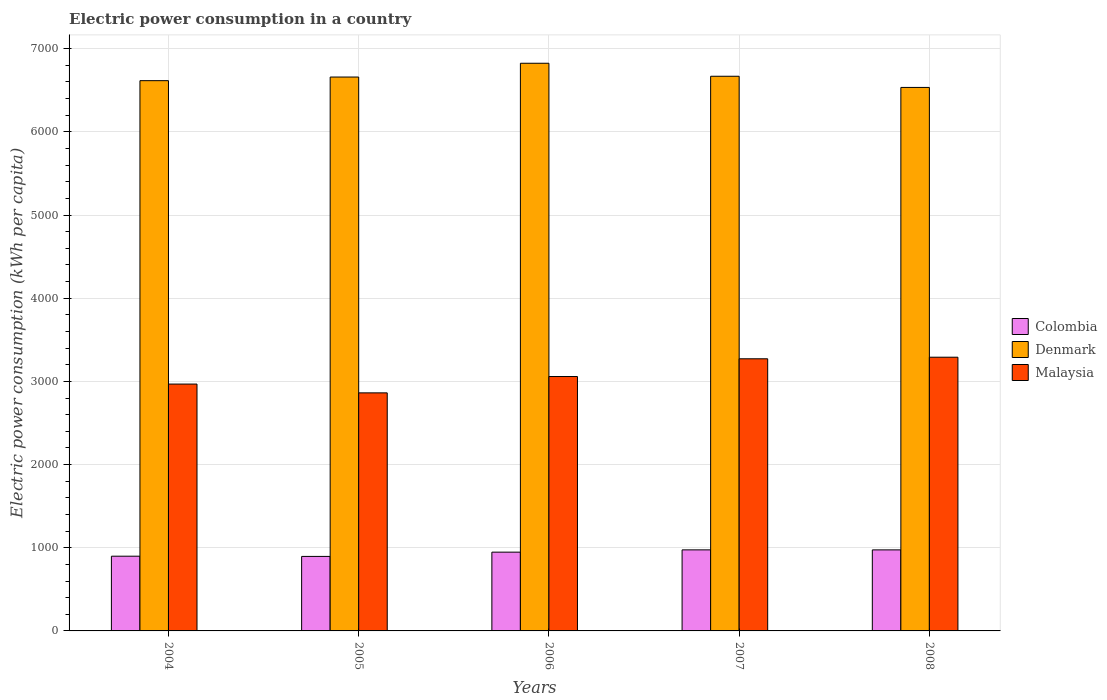How many different coloured bars are there?
Offer a terse response. 3. How many groups of bars are there?
Give a very brief answer. 5. What is the label of the 5th group of bars from the left?
Make the answer very short. 2008. In how many cases, is the number of bars for a given year not equal to the number of legend labels?
Give a very brief answer. 0. What is the electric power consumption in in Colombia in 2005?
Offer a very short reply. 895.82. Across all years, what is the maximum electric power consumption in in Denmark?
Your answer should be very brief. 6824.75. Across all years, what is the minimum electric power consumption in in Denmark?
Offer a terse response. 6534.12. In which year was the electric power consumption in in Colombia minimum?
Offer a terse response. 2005. What is the total electric power consumption in in Denmark in the graph?
Keep it short and to the point. 3.33e+04. What is the difference between the electric power consumption in in Malaysia in 2004 and that in 2007?
Provide a short and direct response. -303.94. What is the difference between the electric power consumption in in Denmark in 2005 and the electric power consumption in in Malaysia in 2004?
Your answer should be compact. 3691.29. What is the average electric power consumption in in Colombia per year?
Give a very brief answer. 937.98. In the year 2004, what is the difference between the electric power consumption in in Malaysia and electric power consumption in in Denmark?
Offer a terse response. -3647.86. What is the ratio of the electric power consumption in in Malaysia in 2006 to that in 2008?
Provide a short and direct response. 0.93. Is the electric power consumption in in Denmark in 2004 less than that in 2006?
Your answer should be very brief. Yes. Is the difference between the electric power consumption in in Malaysia in 2005 and 2006 greater than the difference between the electric power consumption in in Denmark in 2005 and 2006?
Give a very brief answer. No. What is the difference between the highest and the second highest electric power consumption in in Denmark?
Make the answer very short. 156.36. What is the difference between the highest and the lowest electric power consumption in in Malaysia?
Give a very brief answer. 428.77. What does the 1st bar from the right in 2004 represents?
Your answer should be very brief. Malaysia. How many bars are there?
Offer a very short reply. 15. How many years are there in the graph?
Your response must be concise. 5. What is the difference between two consecutive major ticks on the Y-axis?
Provide a short and direct response. 1000. Are the values on the major ticks of Y-axis written in scientific E-notation?
Your answer should be very brief. No. Does the graph contain any zero values?
Provide a short and direct response. No. Does the graph contain grids?
Offer a very short reply. Yes. Where does the legend appear in the graph?
Provide a short and direct response. Center right. What is the title of the graph?
Make the answer very short. Electric power consumption in a country. What is the label or title of the X-axis?
Your response must be concise. Years. What is the label or title of the Y-axis?
Your answer should be compact. Electric power consumption (kWh per capita). What is the Electric power consumption (kWh per capita) in Colombia in 2004?
Give a very brief answer. 898.34. What is the Electric power consumption (kWh per capita) of Denmark in 2004?
Give a very brief answer. 6615.57. What is the Electric power consumption (kWh per capita) of Malaysia in 2004?
Offer a terse response. 2967.71. What is the Electric power consumption (kWh per capita) of Colombia in 2005?
Offer a terse response. 895.82. What is the Electric power consumption (kWh per capita) in Denmark in 2005?
Ensure brevity in your answer.  6659. What is the Electric power consumption (kWh per capita) in Malaysia in 2005?
Offer a very short reply. 2861.98. What is the Electric power consumption (kWh per capita) of Colombia in 2006?
Make the answer very short. 947.13. What is the Electric power consumption (kWh per capita) of Denmark in 2006?
Offer a terse response. 6824.75. What is the Electric power consumption (kWh per capita) in Malaysia in 2006?
Your answer should be very brief. 3058.44. What is the Electric power consumption (kWh per capita) of Colombia in 2007?
Ensure brevity in your answer.  974.39. What is the Electric power consumption (kWh per capita) in Denmark in 2007?
Your response must be concise. 6668.39. What is the Electric power consumption (kWh per capita) in Malaysia in 2007?
Provide a short and direct response. 3271.64. What is the Electric power consumption (kWh per capita) of Colombia in 2008?
Keep it short and to the point. 974.22. What is the Electric power consumption (kWh per capita) in Denmark in 2008?
Make the answer very short. 6534.12. What is the Electric power consumption (kWh per capita) of Malaysia in 2008?
Provide a succinct answer. 3290.75. Across all years, what is the maximum Electric power consumption (kWh per capita) of Colombia?
Your answer should be very brief. 974.39. Across all years, what is the maximum Electric power consumption (kWh per capita) of Denmark?
Ensure brevity in your answer.  6824.75. Across all years, what is the maximum Electric power consumption (kWh per capita) of Malaysia?
Your answer should be very brief. 3290.75. Across all years, what is the minimum Electric power consumption (kWh per capita) of Colombia?
Keep it short and to the point. 895.82. Across all years, what is the minimum Electric power consumption (kWh per capita) of Denmark?
Your answer should be very brief. 6534.12. Across all years, what is the minimum Electric power consumption (kWh per capita) of Malaysia?
Your answer should be compact. 2861.98. What is the total Electric power consumption (kWh per capita) in Colombia in the graph?
Your answer should be compact. 4689.89. What is the total Electric power consumption (kWh per capita) of Denmark in the graph?
Provide a short and direct response. 3.33e+04. What is the total Electric power consumption (kWh per capita) of Malaysia in the graph?
Make the answer very short. 1.55e+04. What is the difference between the Electric power consumption (kWh per capita) of Colombia in 2004 and that in 2005?
Provide a succinct answer. 2.53. What is the difference between the Electric power consumption (kWh per capita) in Denmark in 2004 and that in 2005?
Your answer should be very brief. -43.43. What is the difference between the Electric power consumption (kWh per capita) in Malaysia in 2004 and that in 2005?
Your response must be concise. 105.73. What is the difference between the Electric power consumption (kWh per capita) of Colombia in 2004 and that in 2006?
Provide a short and direct response. -48.78. What is the difference between the Electric power consumption (kWh per capita) of Denmark in 2004 and that in 2006?
Provide a succinct answer. -209.18. What is the difference between the Electric power consumption (kWh per capita) in Malaysia in 2004 and that in 2006?
Your answer should be compact. -90.74. What is the difference between the Electric power consumption (kWh per capita) in Colombia in 2004 and that in 2007?
Your answer should be compact. -76.04. What is the difference between the Electric power consumption (kWh per capita) of Denmark in 2004 and that in 2007?
Offer a very short reply. -52.82. What is the difference between the Electric power consumption (kWh per capita) of Malaysia in 2004 and that in 2007?
Keep it short and to the point. -303.94. What is the difference between the Electric power consumption (kWh per capita) in Colombia in 2004 and that in 2008?
Provide a short and direct response. -75.87. What is the difference between the Electric power consumption (kWh per capita) of Denmark in 2004 and that in 2008?
Ensure brevity in your answer.  81.45. What is the difference between the Electric power consumption (kWh per capita) of Malaysia in 2004 and that in 2008?
Give a very brief answer. -323.05. What is the difference between the Electric power consumption (kWh per capita) in Colombia in 2005 and that in 2006?
Provide a short and direct response. -51.31. What is the difference between the Electric power consumption (kWh per capita) of Denmark in 2005 and that in 2006?
Make the answer very short. -165.75. What is the difference between the Electric power consumption (kWh per capita) in Malaysia in 2005 and that in 2006?
Ensure brevity in your answer.  -196.46. What is the difference between the Electric power consumption (kWh per capita) in Colombia in 2005 and that in 2007?
Make the answer very short. -78.57. What is the difference between the Electric power consumption (kWh per capita) in Denmark in 2005 and that in 2007?
Offer a very short reply. -9.39. What is the difference between the Electric power consumption (kWh per capita) in Malaysia in 2005 and that in 2007?
Give a very brief answer. -409.66. What is the difference between the Electric power consumption (kWh per capita) of Colombia in 2005 and that in 2008?
Keep it short and to the point. -78.4. What is the difference between the Electric power consumption (kWh per capita) in Denmark in 2005 and that in 2008?
Your response must be concise. 124.88. What is the difference between the Electric power consumption (kWh per capita) of Malaysia in 2005 and that in 2008?
Make the answer very short. -428.77. What is the difference between the Electric power consumption (kWh per capita) of Colombia in 2006 and that in 2007?
Your response must be concise. -27.26. What is the difference between the Electric power consumption (kWh per capita) of Denmark in 2006 and that in 2007?
Offer a very short reply. 156.36. What is the difference between the Electric power consumption (kWh per capita) in Malaysia in 2006 and that in 2007?
Keep it short and to the point. -213.2. What is the difference between the Electric power consumption (kWh per capita) of Colombia in 2006 and that in 2008?
Keep it short and to the point. -27.09. What is the difference between the Electric power consumption (kWh per capita) of Denmark in 2006 and that in 2008?
Offer a very short reply. 290.62. What is the difference between the Electric power consumption (kWh per capita) of Malaysia in 2006 and that in 2008?
Provide a short and direct response. -232.31. What is the difference between the Electric power consumption (kWh per capita) in Colombia in 2007 and that in 2008?
Ensure brevity in your answer.  0.17. What is the difference between the Electric power consumption (kWh per capita) of Denmark in 2007 and that in 2008?
Make the answer very short. 134.27. What is the difference between the Electric power consumption (kWh per capita) in Malaysia in 2007 and that in 2008?
Provide a short and direct response. -19.11. What is the difference between the Electric power consumption (kWh per capita) of Colombia in 2004 and the Electric power consumption (kWh per capita) of Denmark in 2005?
Provide a succinct answer. -5760.66. What is the difference between the Electric power consumption (kWh per capita) in Colombia in 2004 and the Electric power consumption (kWh per capita) in Malaysia in 2005?
Give a very brief answer. -1963.64. What is the difference between the Electric power consumption (kWh per capita) of Denmark in 2004 and the Electric power consumption (kWh per capita) of Malaysia in 2005?
Make the answer very short. 3753.59. What is the difference between the Electric power consumption (kWh per capita) of Colombia in 2004 and the Electric power consumption (kWh per capita) of Denmark in 2006?
Offer a very short reply. -5926.4. What is the difference between the Electric power consumption (kWh per capita) in Colombia in 2004 and the Electric power consumption (kWh per capita) in Malaysia in 2006?
Your answer should be very brief. -2160.1. What is the difference between the Electric power consumption (kWh per capita) of Denmark in 2004 and the Electric power consumption (kWh per capita) of Malaysia in 2006?
Provide a succinct answer. 3557.13. What is the difference between the Electric power consumption (kWh per capita) in Colombia in 2004 and the Electric power consumption (kWh per capita) in Denmark in 2007?
Give a very brief answer. -5770.05. What is the difference between the Electric power consumption (kWh per capita) of Colombia in 2004 and the Electric power consumption (kWh per capita) of Malaysia in 2007?
Offer a terse response. -2373.3. What is the difference between the Electric power consumption (kWh per capita) in Denmark in 2004 and the Electric power consumption (kWh per capita) in Malaysia in 2007?
Offer a terse response. 3343.93. What is the difference between the Electric power consumption (kWh per capita) in Colombia in 2004 and the Electric power consumption (kWh per capita) in Denmark in 2008?
Provide a short and direct response. -5635.78. What is the difference between the Electric power consumption (kWh per capita) in Colombia in 2004 and the Electric power consumption (kWh per capita) in Malaysia in 2008?
Make the answer very short. -2392.41. What is the difference between the Electric power consumption (kWh per capita) of Denmark in 2004 and the Electric power consumption (kWh per capita) of Malaysia in 2008?
Provide a succinct answer. 3324.82. What is the difference between the Electric power consumption (kWh per capita) in Colombia in 2005 and the Electric power consumption (kWh per capita) in Denmark in 2006?
Offer a very short reply. -5928.93. What is the difference between the Electric power consumption (kWh per capita) of Colombia in 2005 and the Electric power consumption (kWh per capita) of Malaysia in 2006?
Your answer should be very brief. -2162.62. What is the difference between the Electric power consumption (kWh per capita) in Denmark in 2005 and the Electric power consumption (kWh per capita) in Malaysia in 2006?
Offer a very short reply. 3600.56. What is the difference between the Electric power consumption (kWh per capita) of Colombia in 2005 and the Electric power consumption (kWh per capita) of Denmark in 2007?
Offer a very short reply. -5772.57. What is the difference between the Electric power consumption (kWh per capita) in Colombia in 2005 and the Electric power consumption (kWh per capita) in Malaysia in 2007?
Offer a very short reply. -2375.83. What is the difference between the Electric power consumption (kWh per capita) in Denmark in 2005 and the Electric power consumption (kWh per capita) in Malaysia in 2007?
Provide a short and direct response. 3387.36. What is the difference between the Electric power consumption (kWh per capita) in Colombia in 2005 and the Electric power consumption (kWh per capita) in Denmark in 2008?
Ensure brevity in your answer.  -5638.31. What is the difference between the Electric power consumption (kWh per capita) of Colombia in 2005 and the Electric power consumption (kWh per capita) of Malaysia in 2008?
Keep it short and to the point. -2394.94. What is the difference between the Electric power consumption (kWh per capita) of Denmark in 2005 and the Electric power consumption (kWh per capita) of Malaysia in 2008?
Provide a short and direct response. 3368.25. What is the difference between the Electric power consumption (kWh per capita) of Colombia in 2006 and the Electric power consumption (kWh per capita) of Denmark in 2007?
Offer a very short reply. -5721.26. What is the difference between the Electric power consumption (kWh per capita) of Colombia in 2006 and the Electric power consumption (kWh per capita) of Malaysia in 2007?
Make the answer very short. -2324.52. What is the difference between the Electric power consumption (kWh per capita) in Denmark in 2006 and the Electric power consumption (kWh per capita) in Malaysia in 2007?
Your answer should be very brief. 3553.1. What is the difference between the Electric power consumption (kWh per capita) in Colombia in 2006 and the Electric power consumption (kWh per capita) in Denmark in 2008?
Make the answer very short. -5587. What is the difference between the Electric power consumption (kWh per capita) of Colombia in 2006 and the Electric power consumption (kWh per capita) of Malaysia in 2008?
Your answer should be compact. -2343.63. What is the difference between the Electric power consumption (kWh per capita) of Denmark in 2006 and the Electric power consumption (kWh per capita) of Malaysia in 2008?
Your answer should be compact. 3533.99. What is the difference between the Electric power consumption (kWh per capita) in Colombia in 2007 and the Electric power consumption (kWh per capita) in Denmark in 2008?
Offer a terse response. -5559.74. What is the difference between the Electric power consumption (kWh per capita) of Colombia in 2007 and the Electric power consumption (kWh per capita) of Malaysia in 2008?
Offer a terse response. -2316.37. What is the difference between the Electric power consumption (kWh per capita) of Denmark in 2007 and the Electric power consumption (kWh per capita) of Malaysia in 2008?
Provide a short and direct response. 3377.64. What is the average Electric power consumption (kWh per capita) of Colombia per year?
Give a very brief answer. 937.98. What is the average Electric power consumption (kWh per capita) in Denmark per year?
Your answer should be compact. 6660.37. What is the average Electric power consumption (kWh per capita) in Malaysia per year?
Ensure brevity in your answer.  3090.1. In the year 2004, what is the difference between the Electric power consumption (kWh per capita) of Colombia and Electric power consumption (kWh per capita) of Denmark?
Keep it short and to the point. -5717.23. In the year 2004, what is the difference between the Electric power consumption (kWh per capita) of Colombia and Electric power consumption (kWh per capita) of Malaysia?
Keep it short and to the point. -2069.36. In the year 2004, what is the difference between the Electric power consumption (kWh per capita) in Denmark and Electric power consumption (kWh per capita) in Malaysia?
Your response must be concise. 3647.86. In the year 2005, what is the difference between the Electric power consumption (kWh per capita) in Colombia and Electric power consumption (kWh per capita) in Denmark?
Keep it short and to the point. -5763.18. In the year 2005, what is the difference between the Electric power consumption (kWh per capita) of Colombia and Electric power consumption (kWh per capita) of Malaysia?
Provide a succinct answer. -1966.16. In the year 2005, what is the difference between the Electric power consumption (kWh per capita) in Denmark and Electric power consumption (kWh per capita) in Malaysia?
Ensure brevity in your answer.  3797.02. In the year 2006, what is the difference between the Electric power consumption (kWh per capita) of Colombia and Electric power consumption (kWh per capita) of Denmark?
Provide a succinct answer. -5877.62. In the year 2006, what is the difference between the Electric power consumption (kWh per capita) in Colombia and Electric power consumption (kWh per capita) in Malaysia?
Give a very brief answer. -2111.32. In the year 2006, what is the difference between the Electric power consumption (kWh per capita) in Denmark and Electric power consumption (kWh per capita) in Malaysia?
Provide a succinct answer. 3766.3. In the year 2007, what is the difference between the Electric power consumption (kWh per capita) of Colombia and Electric power consumption (kWh per capita) of Denmark?
Ensure brevity in your answer.  -5694.01. In the year 2007, what is the difference between the Electric power consumption (kWh per capita) in Colombia and Electric power consumption (kWh per capita) in Malaysia?
Your answer should be very brief. -2297.26. In the year 2007, what is the difference between the Electric power consumption (kWh per capita) of Denmark and Electric power consumption (kWh per capita) of Malaysia?
Your response must be concise. 3396.75. In the year 2008, what is the difference between the Electric power consumption (kWh per capita) in Colombia and Electric power consumption (kWh per capita) in Denmark?
Your answer should be compact. -5559.91. In the year 2008, what is the difference between the Electric power consumption (kWh per capita) of Colombia and Electric power consumption (kWh per capita) of Malaysia?
Offer a terse response. -2316.54. In the year 2008, what is the difference between the Electric power consumption (kWh per capita) in Denmark and Electric power consumption (kWh per capita) in Malaysia?
Your answer should be compact. 3243.37. What is the ratio of the Electric power consumption (kWh per capita) in Colombia in 2004 to that in 2005?
Offer a terse response. 1. What is the ratio of the Electric power consumption (kWh per capita) of Malaysia in 2004 to that in 2005?
Your answer should be very brief. 1.04. What is the ratio of the Electric power consumption (kWh per capita) in Colombia in 2004 to that in 2006?
Offer a terse response. 0.95. What is the ratio of the Electric power consumption (kWh per capita) in Denmark in 2004 to that in 2006?
Make the answer very short. 0.97. What is the ratio of the Electric power consumption (kWh per capita) of Malaysia in 2004 to that in 2006?
Make the answer very short. 0.97. What is the ratio of the Electric power consumption (kWh per capita) of Colombia in 2004 to that in 2007?
Your answer should be very brief. 0.92. What is the ratio of the Electric power consumption (kWh per capita) in Malaysia in 2004 to that in 2007?
Your answer should be compact. 0.91. What is the ratio of the Electric power consumption (kWh per capita) of Colombia in 2004 to that in 2008?
Ensure brevity in your answer.  0.92. What is the ratio of the Electric power consumption (kWh per capita) in Denmark in 2004 to that in 2008?
Offer a terse response. 1.01. What is the ratio of the Electric power consumption (kWh per capita) in Malaysia in 2004 to that in 2008?
Provide a succinct answer. 0.9. What is the ratio of the Electric power consumption (kWh per capita) in Colombia in 2005 to that in 2006?
Offer a terse response. 0.95. What is the ratio of the Electric power consumption (kWh per capita) of Denmark in 2005 to that in 2006?
Keep it short and to the point. 0.98. What is the ratio of the Electric power consumption (kWh per capita) of Malaysia in 2005 to that in 2006?
Offer a very short reply. 0.94. What is the ratio of the Electric power consumption (kWh per capita) in Colombia in 2005 to that in 2007?
Provide a succinct answer. 0.92. What is the ratio of the Electric power consumption (kWh per capita) of Malaysia in 2005 to that in 2007?
Your answer should be compact. 0.87. What is the ratio of the Electric power consumption (kWh per capita) in Colombia in 2005 to that in 2008?
Your response must be concise. 0.92. What is the ratio of the Electric power consumption (kWh per capita) of Denmark in 2005 to that in 2008?
Offer a terse response. 1.02. What is the ratio of the Electric power consumption (kWh per capita) in Malaysia in 2005 to that in 2008?
Your answer should be very brief. 0.87. What is the ratio of the Electric power consumption (kWh per capita) of Colombia in 2006 to that in 2007?
Your response must be concise. 0.97. What is the ratio of the Electric power consumption (kWh per capita) in Denmark in 2006 to that in 2007?
Your answer should be very brief. 1.02. What is the ratio of the Electric power consumption (kWh per capita) in Malaysia in 2006 to that in 2007?
Ensure brevity in your answer.  0.93. What is the ratio of the Electric power consumption (kWh per capita) in Colombia in 2006 to that in 2008?
Your answer should be very brief. 0.97. What is the ratio of the Electric power consumption (kWh per capita) of Denmark in 2006 to that in 2008?
Provide a short and direct response. 1.04. What is the ratio of the Electric power consumption (kWh per capita) of Malaysia in 2006 to that in 2008?
Provide a short and direct response. 0.93. What is the ratio of the Electric power consumption (kWh per capita) in Denmark in 2007 to that in 2008?
Ensure brevity in your answer.  1.02. What is the difference between the highest and the second highest Electric power consumption (kWh per capita) in Colombia?
Your response must be concise. 0.17. What is the difference between the highest and the second highest Electric power consumption (kWh per capita) in Denmark?
Your response must be concise. 156.36. What is the difference between the highest and the second highest Electric power consumption (kWh per capita) of Malaysia?
Offer a terse response. 19.11. What is the difference between the highest and the lowest Electric power consumption (kWh per capita) in Colombia?
Your response must be concise. 78.57. What is the difference between the highest and the lowest Electric power consumption (kWh per capita) of Denmark?
Keep it short and to the point. 290.62. What is the difference between the highest and the lowest Electric power consumption (kWh per capita) in Malaysia?
Your answer should be very brief. 428.77. 